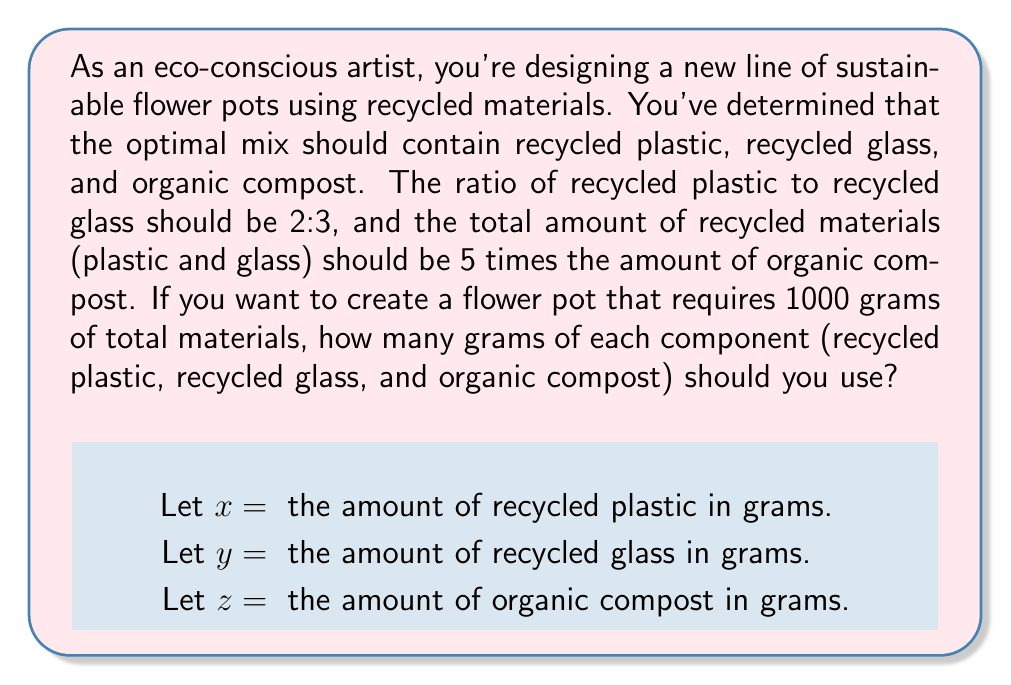Can you solve this math problem? To solve this problem, we'll use a system of linear equations based on the given information:

1. The ratio of recycled plastic to recycled glass is 2:3:
   $$\frac{x}{y} = \frac{2}{3}$$

2. The total amount of recycled materials (plastic and glass) is 5 times the amount of organic compost:
   $$x + y = 5z$$

3. The total amount of materials is 1000 grams:
   $$x + y + z = 1000$$

Let's solve this system step by step:

Step 1: Express y in terms of x using equation 1:
$$y = \frac{3x}{2}$$

Step 2: Substitute this expression into equation 2:
$$x + \frac{3x}{2} = 5z$$
$$\frac{2x}{2} + \frac{3x}{2} = 5z$$
$$\frac{5x}{2} = 5z$$
$$x = 2z$$

Step 3: Substitute the expressions for x and y into equation 3:
$$2z + \frac{3(2z)}{2} + z = 1000$$
$$2z + 3z + z = 1000$$
$$6z = 1000$$
$$z = \frac{1000}{6} \approx 166.67$$

Step 4: Calculate x and y:
$$x = 2z = 2 \cdot 166.67 \approx 333.33$$
$$y = \frac{3x}{2} = \frac{3 \cdot 333.33}{2} = 500$$

Therefore, the optimal amounts for each component are:
Recycled plastic (x): 333.33 grams
Recycled glass (y): 500 grams
Organic compost (z): 166.67 grams
Answer: Recycled plastic: 333.33 grams
Recycled glass: 500 grams
Organic compost: 166.67 grams 